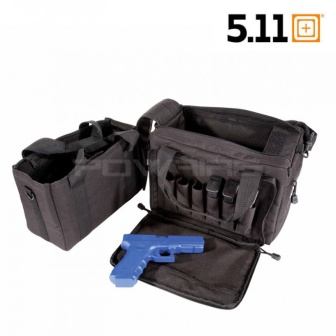Can you describe the main features of this image for me? The image showcases a robust black tactical bag with a practical and versatile design, resting against a stark white background. This multifunctional bag features numerous pockets and storage compartments, including one that openly displays a conspicuous blue toy gun, hinting at the spacious and organized interior which can accommodate diverse items from toys to tools. Its durable fabric and structured layout suggest suitability for demanding situations or adventure gear storage. Notably, the logo '5.11', visible on the top right corner, suggests a link to a renowned brand known for specialized tactical equipment. 